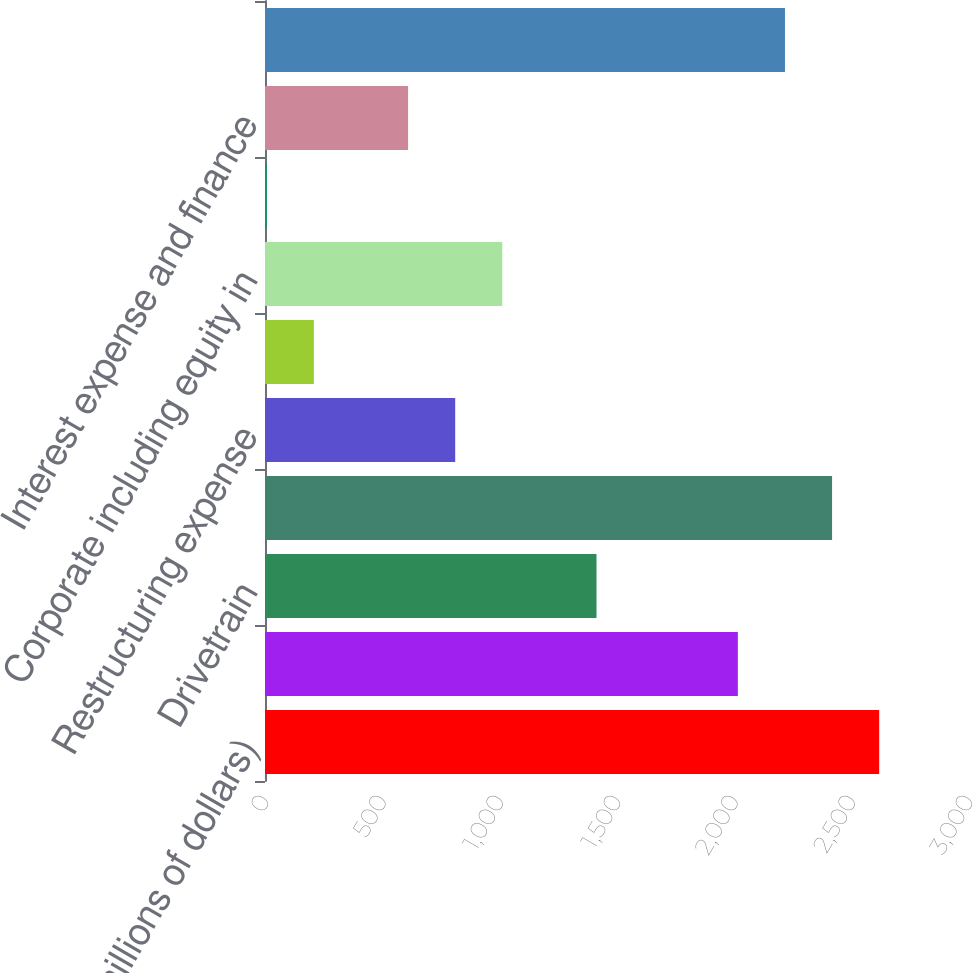Convert chart. <chart><loc_0><loc_0><loc_500><loc_500><bar_chart><fcel>(millions of dollars)<fcel>Engine<fcel>Drivetrain<fcel>Adjusted EBIT<fcel>Restructuring expense<fcel>Merger and acquisition expense<fcel>Corporate including equity in<fcel>Interest income<fcel>Interest expense and finance<fcel>Earnings before income taxes<nl><fcel>2617.25<fcel>2015<fcel>1412.75<fcel>2416.5<fcel>810.5<fcel>208.25<fcel>1011.25<fcel>7.5<fcel>609.75<fcel>2215.75<nl></chart> 